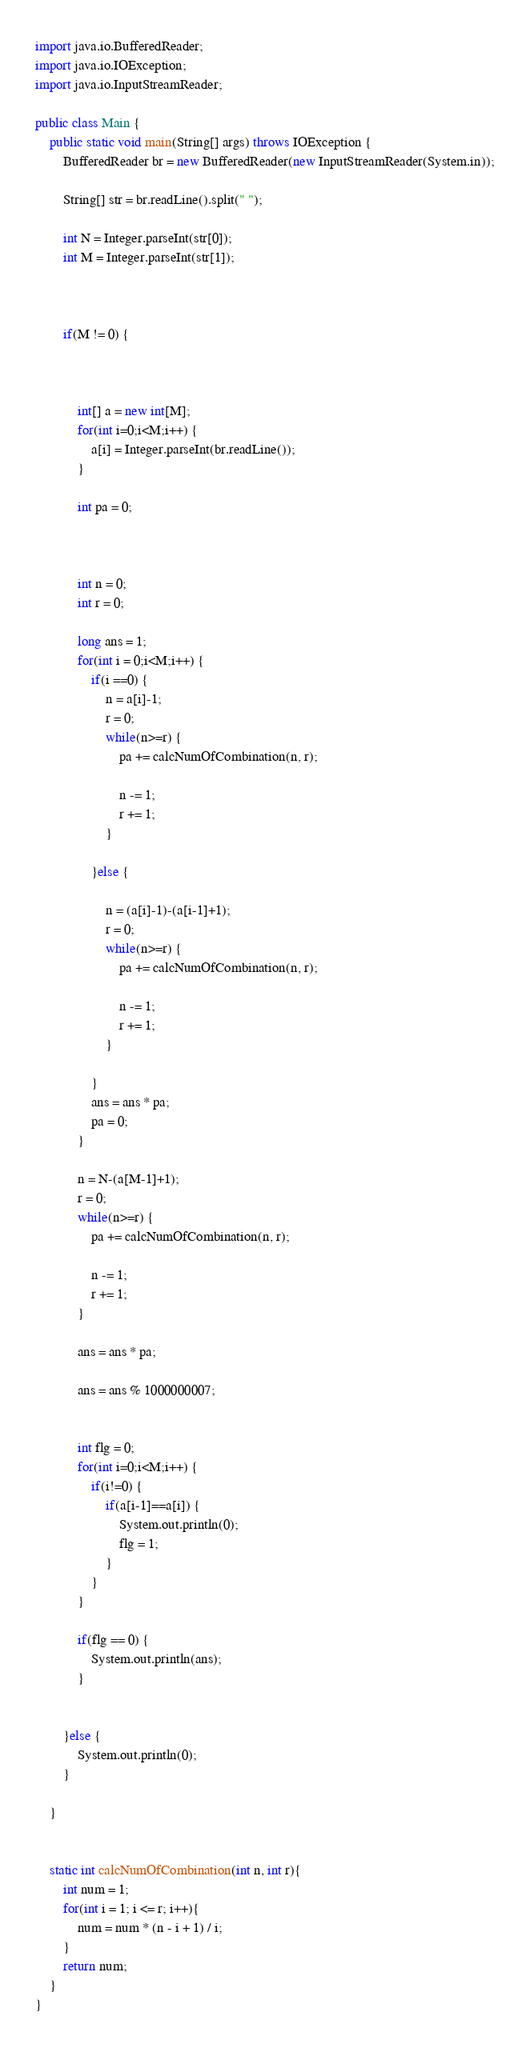Convert code to text. <code><loc_0><loc_0><loc_500><loc_500><_Java_>import java.io.BufferedReader;
import java.io.IOException;
import java.io.InputStreamReader;

public class Main {
	public static void main(String[] args) throws IOException {
		BufferedReader br = new BufferedReader(new InputStreamReader(System.in));

		String[] str = br.readLine().split(" ");

		int N = Integer.parseInt(str[0]);
		int M = Integer.parseInt(str[1]);



		if(M != 0) {



			int[] a = new int[M];
			for(int i=0;i<M;i++) {
				a[i] = Integer.parseInt(br.readLine());
			}

			int pa = 0;



			int n = 0;
			int r = 0;

			long ans = 1;
			for(int i = 0;i<M;i++) {
				if(i ==0) {
					n = a[i]-1;
					r = 0;
					while(n>=r) {
						pa += calcNumOfCombination(n, r);

						n -= 1;
						r += 1;
					}

				}else {

					n = (a[i]-1)-(a[i-1]+1);
					r = 0;
					while(n>=r) {
						pa += calcNumOfCombination(n, r);

						n -= 1;
						r += 1;
					}

				}
				ans = ans * pa;
				pa = 0;
			}

			n = N-(a[M-1]+1);
			r = 0;
			while(n>=r) {
				pa += calcNumOfCombination(n, r);

				n -= 1;
				r += 1;
			}

			ans = ans * pa;

			ans = ans % 1000000007;


			int flg = 0;
			for(int i=0;i<M;i++) {
				if(i!=0) {
					if(a[i-1]==a[i]) {
						System.out.println(0);
						flg = 1;
					}
				}
			}

			if(flg == 0) {
				System.out.println(ans);
			}


		}else {
			System.out.println(0);
		}

	}


    static int calcNumOfCombination(int n, int r){
        int num = 1;
        for(int i = 1; i <= r; i++){
            num = num * (n - i + 1) / i;
        }
        return num;
    }
}
</code> 